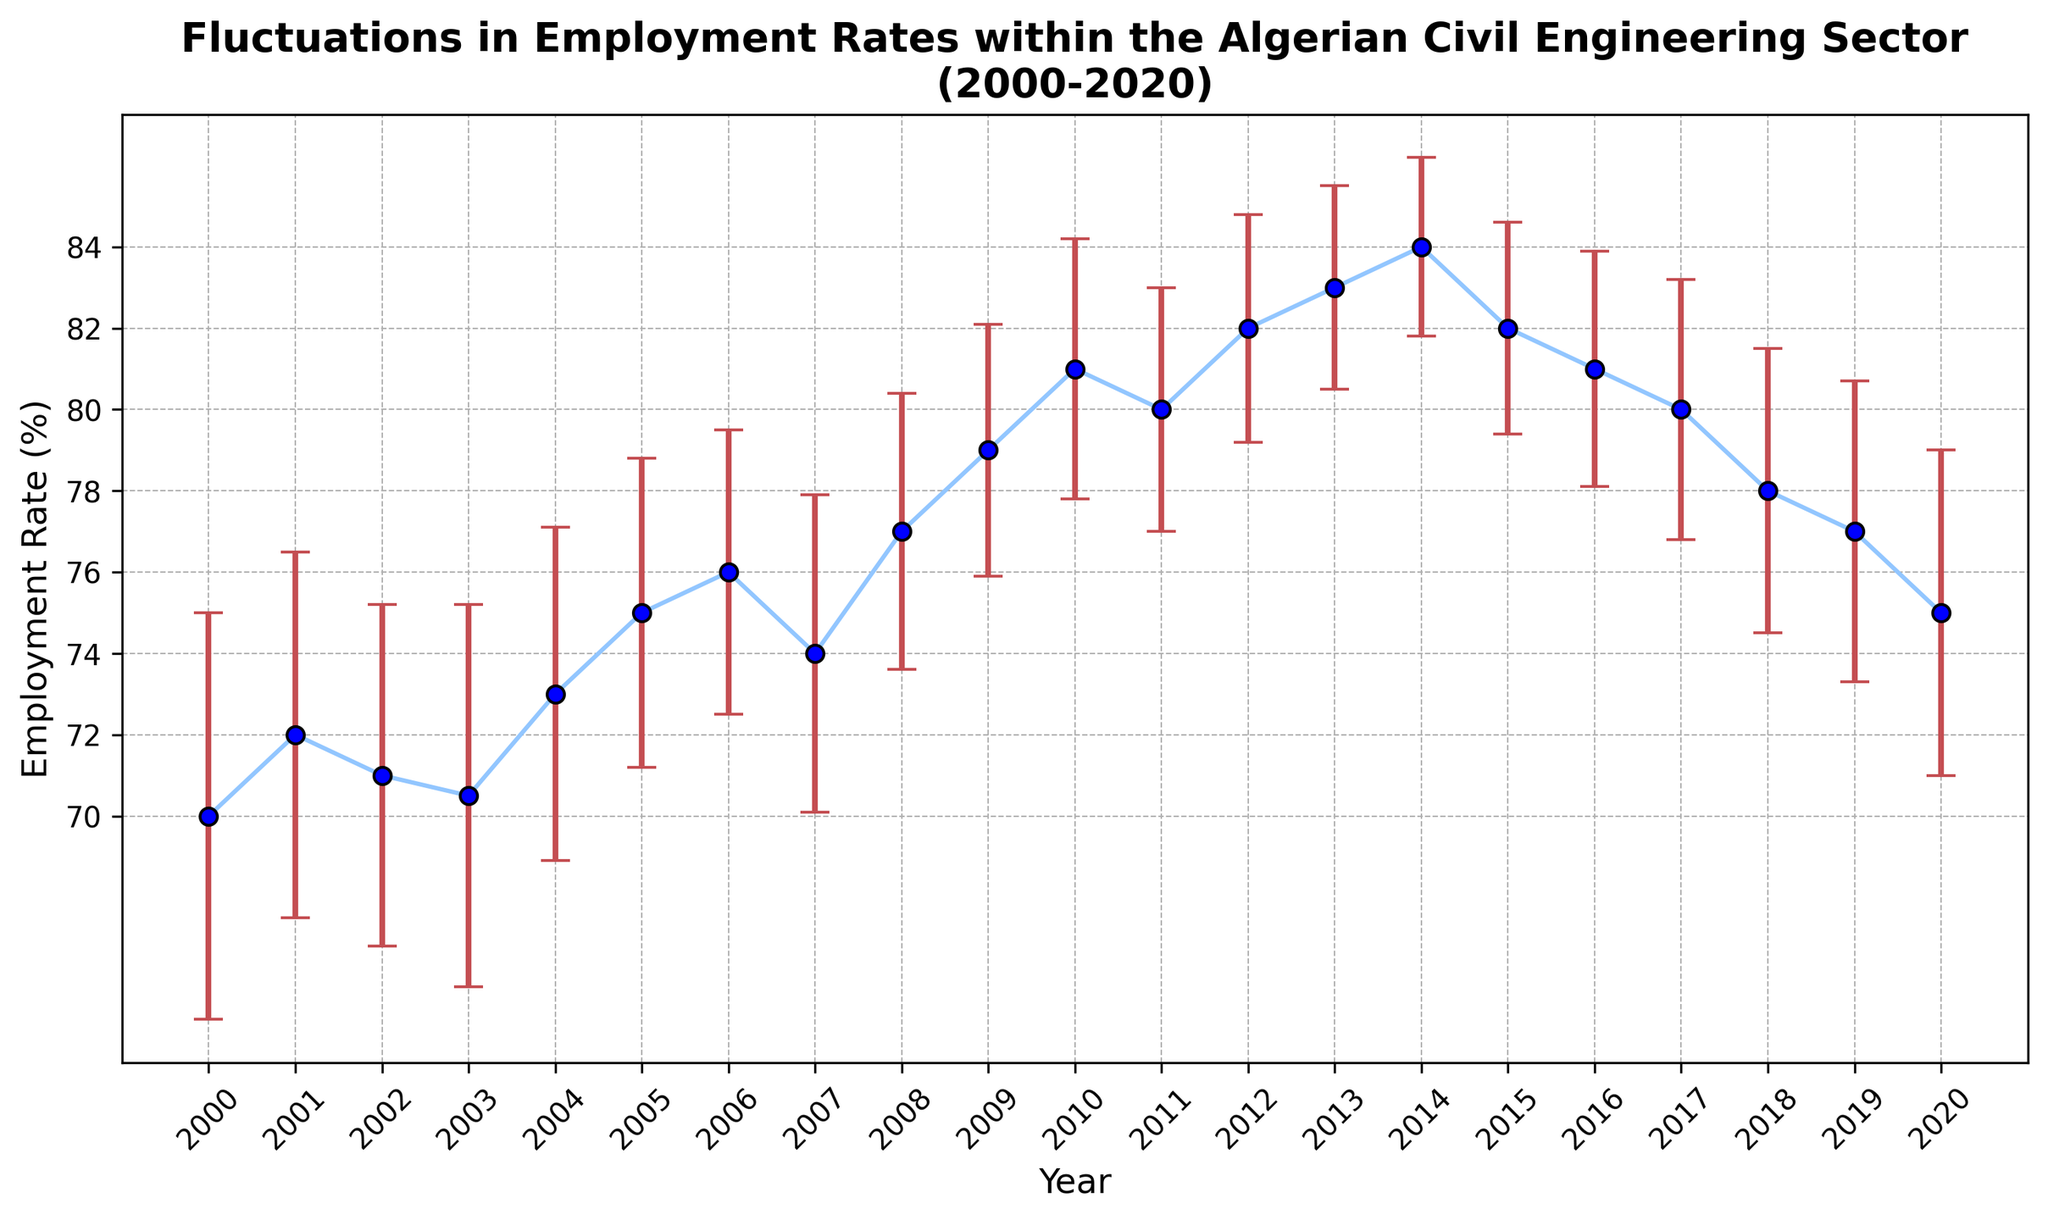Which year had the highest employment rate? The year with the highest employment rate is the one with the highest point on the y-axis (employment rate) in the figure.
Answer: 2014 What is the average employment rate for the years 2015 to 2020? Sum the employment rates for 2015 to 2020 (82 + 81 + 80 + 78 + 77 + 75) and then divide by the number of years (6). (82 + 81 + 80 + 78 + 77 + 75) / 6 = 473 / 6 ≈ 78.83
Answer: 78.83 By how much did the employment rate change from 2000 to 2020? Find the difference in employment rates between the years 2020 and 2000. 75 (2020) - 70 (2000) = 5
Answer: 5 Which year had the smallest error bar? Identify the year with the shortest error bar length. This can be visually seen by comparing the error bar lengths in the figure.
Answer: 2014 Compare the employment rate between the years 2005 and 2015, and state which is higher. The employment rate in 2005 (75) and in 2015 (82). 82 > 75, so 2015 has a higher employment rate.
Answer: 2015 What is the overall trend in employment rates from 2000 to 2020? Evaluate the general direction of the employment rate points from 2000 to 2020; it's clear that the employment rate generally increases over this period.
Answer: Increasing What is the difference between the maximum and minimum error bars shown in the figure? Identify the maximum error bar (5 in 2000) and the minimum error bar (2.2 in 2014), then subtract the minimum from the maximum. 5 - 2.2 = 2.8
Answer: 2.8 In which year was the employment rate least affected by economic challenges, as indicated by the smallest error bar? The year with the smallest error bar represents the least economic challenges.
Answer: 2014 How does the employment rate in 2010 compare to 2020? Compare the employment rates for 2010 (81) and 2020 (75). 81 > 75, so the employment rate in 2010 is higher.
Answer: 2010 What is the average error bar length over the years 2000-2020? Sum the lengths of all error bars from 2000-2020 and divide by the number of years (21). (5 + 4.5 + 4.2 + 4.7 + 4.1 + 3.8 + 3.5 + 3.9 + 3.4 + 3.1 + 3.2 + 3.0 + 2.8 + 2.5 + 2.2 + 2.6 + 2.9 + 3.2 + 3.5 + 3.7 + 4.0) / 21 ≈ 3.57
Answer: 3.57 